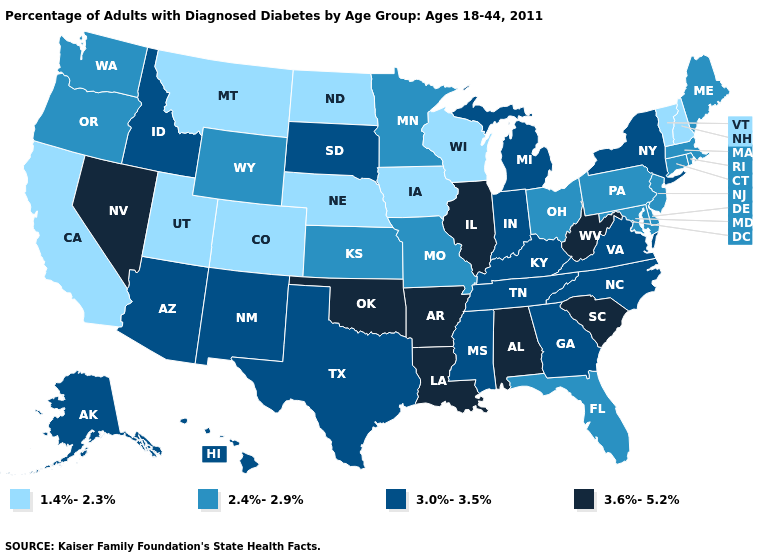Which states hav the highest value in the Northeast?
Concise answer only. New York. Among the states that border North Dakota , which have the lowest value?
Short answer required. Montana. Does the first symbol in the legend represent the smallest category?
Concise answer only. Yes. What is the value of Rhode Island?
Write a very short answer. 2.4%-2.9%. What is the lowest value in the USA?
Keep it brief. 1.4%-2.3%. What is the value of Alabama?
Be succinct. 3.6%-5.2%. Which states have the lowest value in the Northeast?
Answer briefly. New Hampshire, Vermont. What is the highest value in the USA?
Answer briefly. 3.6%-5.2%. Which states have the highest value in the USA?
Give a very brief answer. Alabama, Arkansas, Illinois, Louisiana, Nevada, Oklahoma, South Carolina, West Virginia. Among the states that border Oregon , which have the highest value?
Answer briefly. Nevada. Does West Virginia have a higher value than Arizona?
Give a very brief answer. Yes. What is the lowest value in the USA?
Quick response, please. 1.4%-2.3%. What is the highest value in the Northeast ?
Give a very brief answer. 3.0%-3.5%. Does Montana have the lowest value in the West?
Concise answer only. Yes. What is the value of Maryland?
Be succinct. 2.4%-2.9%. 